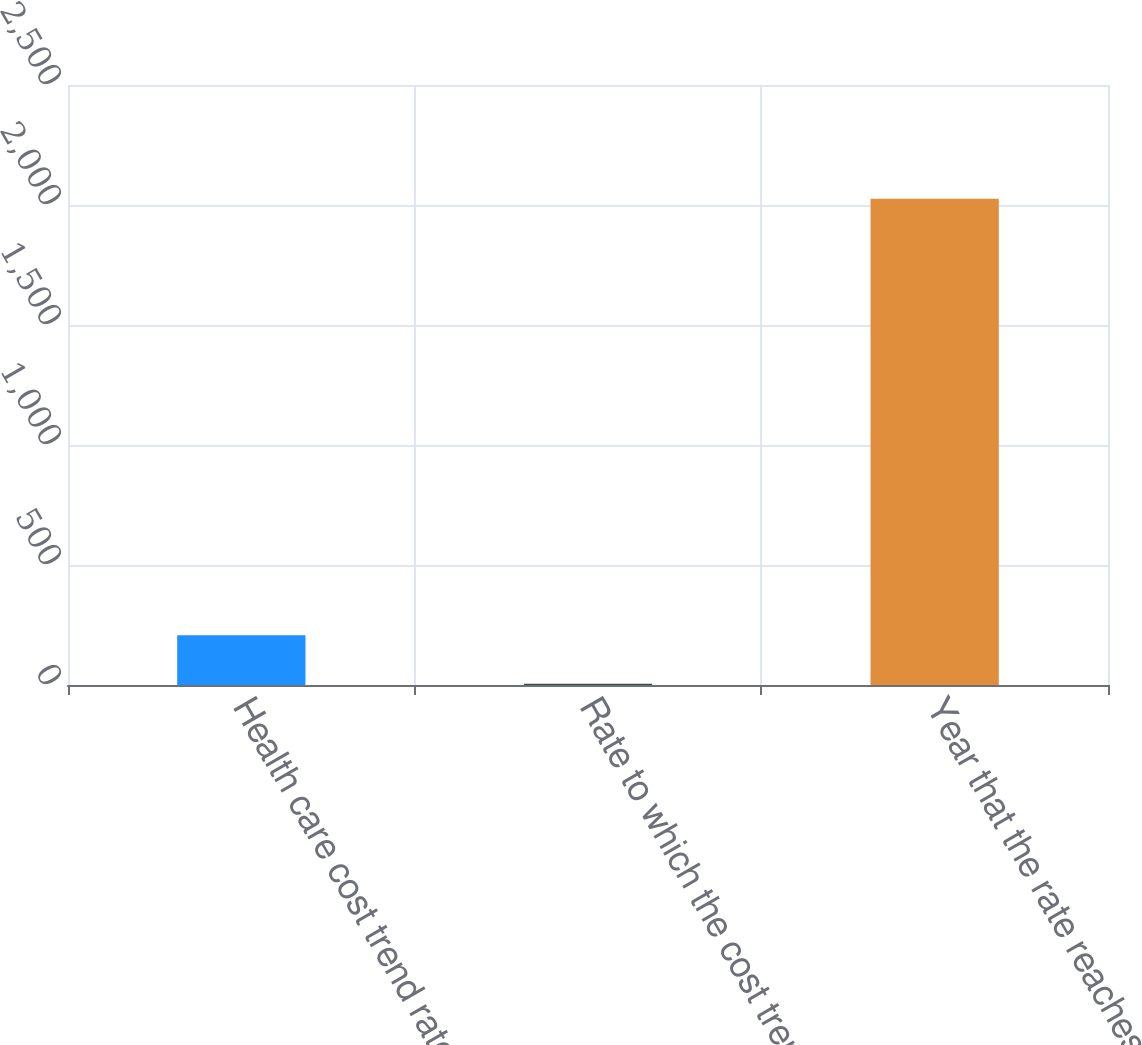Convert chart. <chart><loc_0><loc_0><loc_500><loc_500><bar_chart><fcel>Health care cost trend rate<fcel>Rate to which the cost trend<fcel>Year that the rate reaches the<nl><fcel>207.1<fcel>5<fcel>2026<nl></chart> 